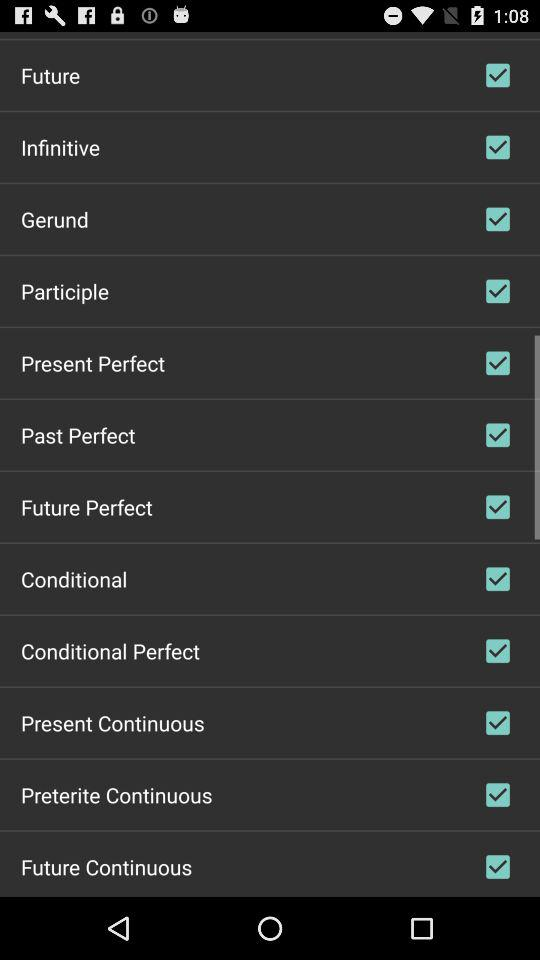What is the status of "Future"? The status is "on". 